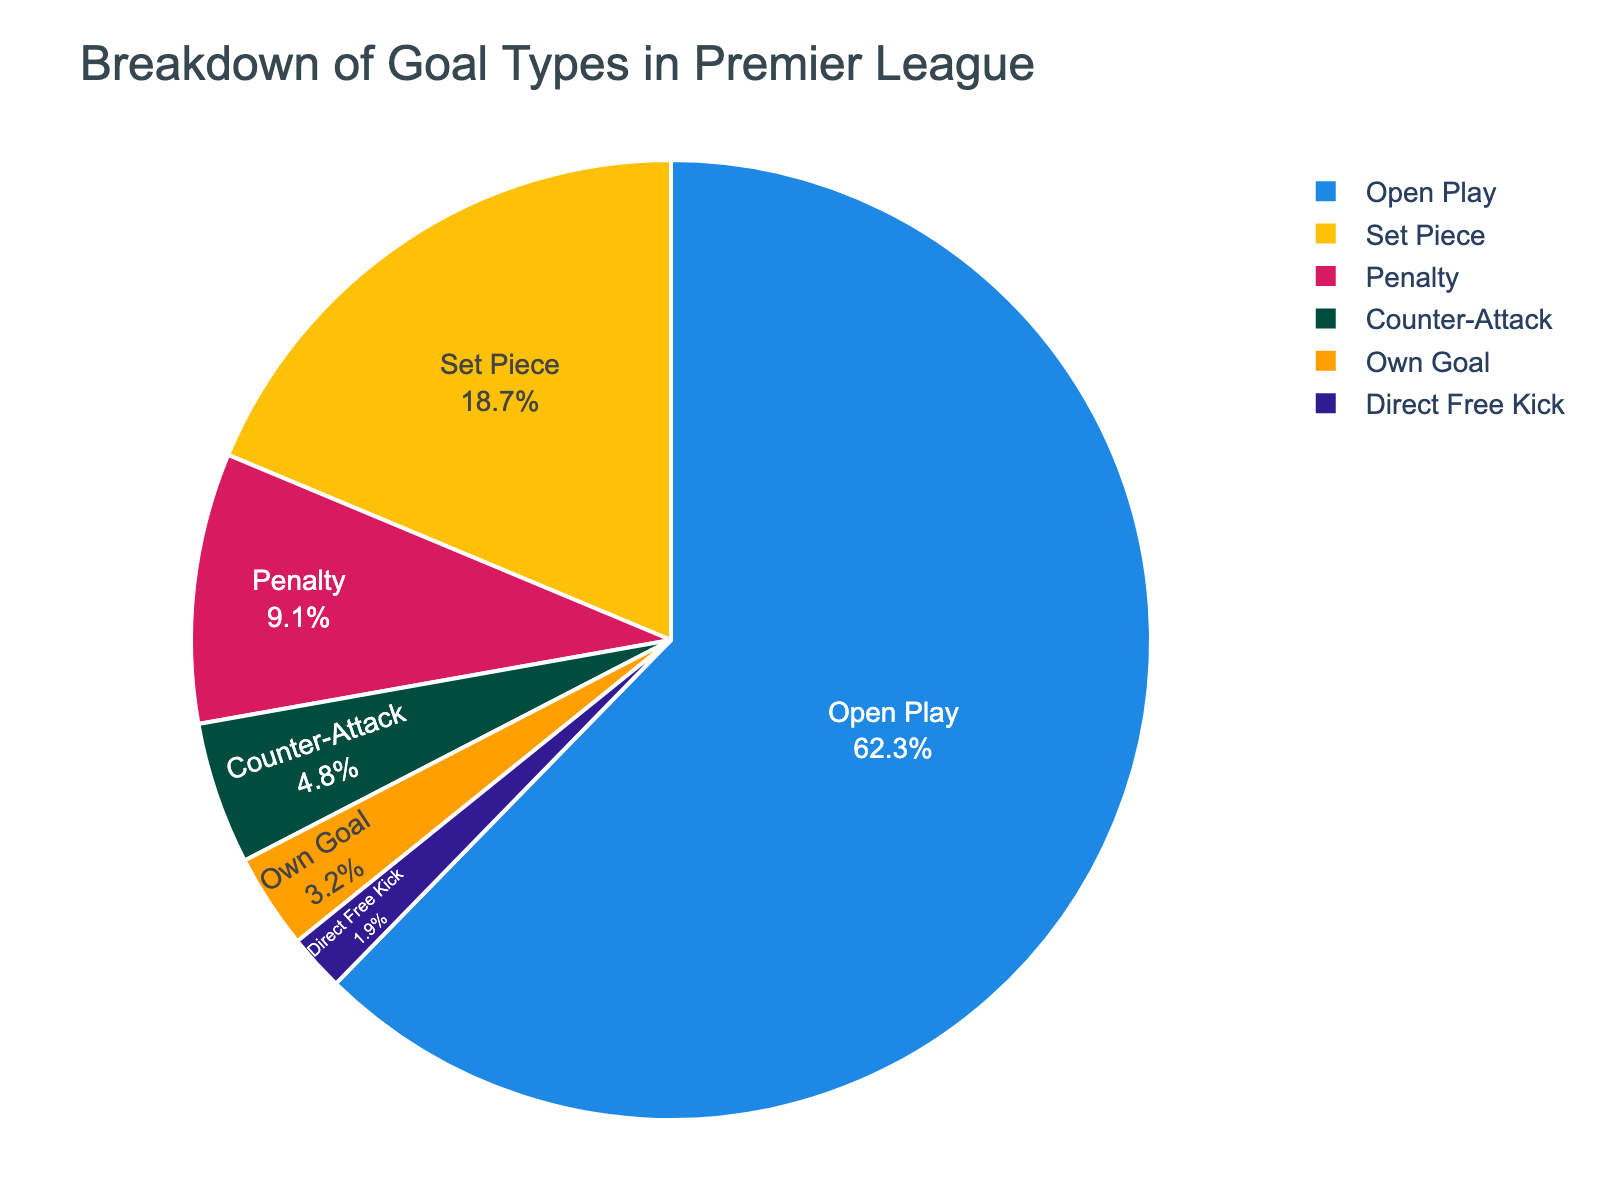What percentage of goals come from penalties and own goals combined? First, identify the percentage of goals from penalties (9.1%) and own goals (3.2%). Then, add these two percentages together: 9.1 + 3.2 = 12.3%.
Answer: 12.3% What type of goal contributes the least to the total goals scored, and what percentage is it? Find the goal type with the smallest percentage. Direct Free Kick has the smallest percentage at 1.9%.
Answer: Direct Free Kick, 1.9% How much higher is the percentage of goals from open play compared to counter-attacks? First, identify the percentage of goals from open play (62.3%) and counter-attacks (4.8%). Subtract the percentage for counter-attacks from that of open play: 62.3 - 4.8 = 57.5%.
Answer: 57.5% What proportion of goals are scored from open play compared to the total percentage of goals from set pieces and penalties combined? Identify the percentage for open play goals (62.3%), set pieces (18.7%), and penalties (9.1%). Add set pieces and penalties: 18.7 + 9.1 = 27.8%. Compare open play to this combined percentage: 62.3% (open play) / 27.8% (set pieces + penalties) ≈ 2.24 times more.
Answer: 2.24 times more Among set pieces, penalties, and own goals, which type of goal is the most frequent and which is the least frequent? Identify the percentages: set pieces (18.7%), penalties (9.1%), and own goals (3.2%). Set pieces have the highest percentage and own goals the lowest.
Answer: Most frequent: Set Pieces; Least frequent: Own Goals How much less frequent are direct free kicks compared to penalties? Find the percentages for direct free kicks (1.9%) and penalties (9.1%). Subtract the percentage for direct free kicks from that of penalties: 9.1 - 1.9 = 7.2%.
Answer: 7.2% less frequent If a goal is not from open play, what is the most likely type of goal it is? Exclude open play (62.3%) and find the highest percentage among the remaining types. Set pieces have the highest percentage at 18.7%.
Answer: Set Piece Is the combined percentage of counter-attacks and direct free kicks higher or lower than penalties? Identify the percentages: counter-attacks (4.8%), direct free kicks (1.9%), and penalties (9.1%). Add counter-attacks and direct free kicks: 4.8 + 1.9 = 6.7%. Since this is lower than 9.1%, the combined percentage is lower.
Answer: Lower What is the difference in percentage between the most common and the least common type of goals? Identify the highest and lowest percentages: open play (62.3%) and direct free kicks (1.9%). Subtract the lowest percentage from the highest: 62.3 - 1.9 = 60.4%.
Answer: 60.4% 